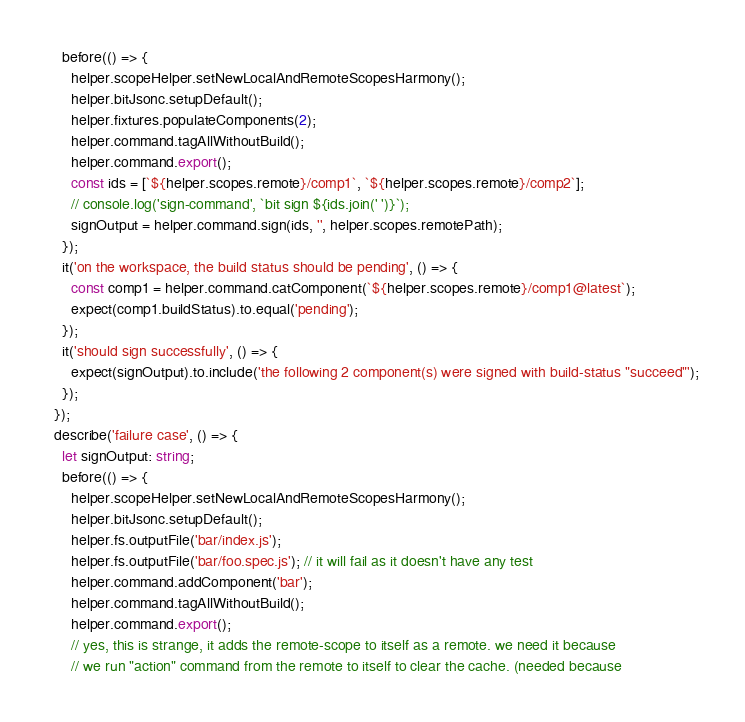<code> <loc_0><loc_0><loc_500><loc_500><_TypeScript_>    before(() => {
      helper.scopeHelper.setNewLocalAndRemoteScopesHarmony();
      helper.bitJsonc.setupDefault();
      helper.fixtures.populateComponents(2);
      helper.command.tagAllWithoutBuild();
      helper.command.export();
      const ids = [`${helper.scopes.remote}/comp1`, `${helper.scopes.remote}/comp2`];
      // console.log('sign-command', `bit sign ${ids.join(' ')}`);
      signOutput = helper.command.sign(ids, '', helper.scopes.remotePath);
    });
    it('on the workspace, the build status should be pending', () => {
      const comp1 = helper.command.catComponent(`${helper.scopes.remote}/comp1@latest`);
      expect(comp1.buildStatus).to.equal('pending');
    });
    it('should sign successfully', () => {
      expect(signOutput).to.include('the following 2 component(s) were signed with build-status "succeed"');
    });
  });
  describe('failure case', () => {
    let signOutput: string;
    before(() => {
      helper.scopeHelper.setNewLocalAndRemoteScopesHarmony();
      helper.bitJsonc.setupDefault();
      helper.fs.outputFile('bar/index.js');
      helper.fs.outputFile('bar/foo.spec.js'); // it will fail as it doesn't have any test
      helper.command.addComponent('bar');
      helper.command.tagAllWithoutBuild();
      helper.command.export();
      // yes, this is strange, it adds the remote-scope to itself as a remote. we need it because
      // we run "action" command from the remote to itself to clear the cache. (needed because</code> 